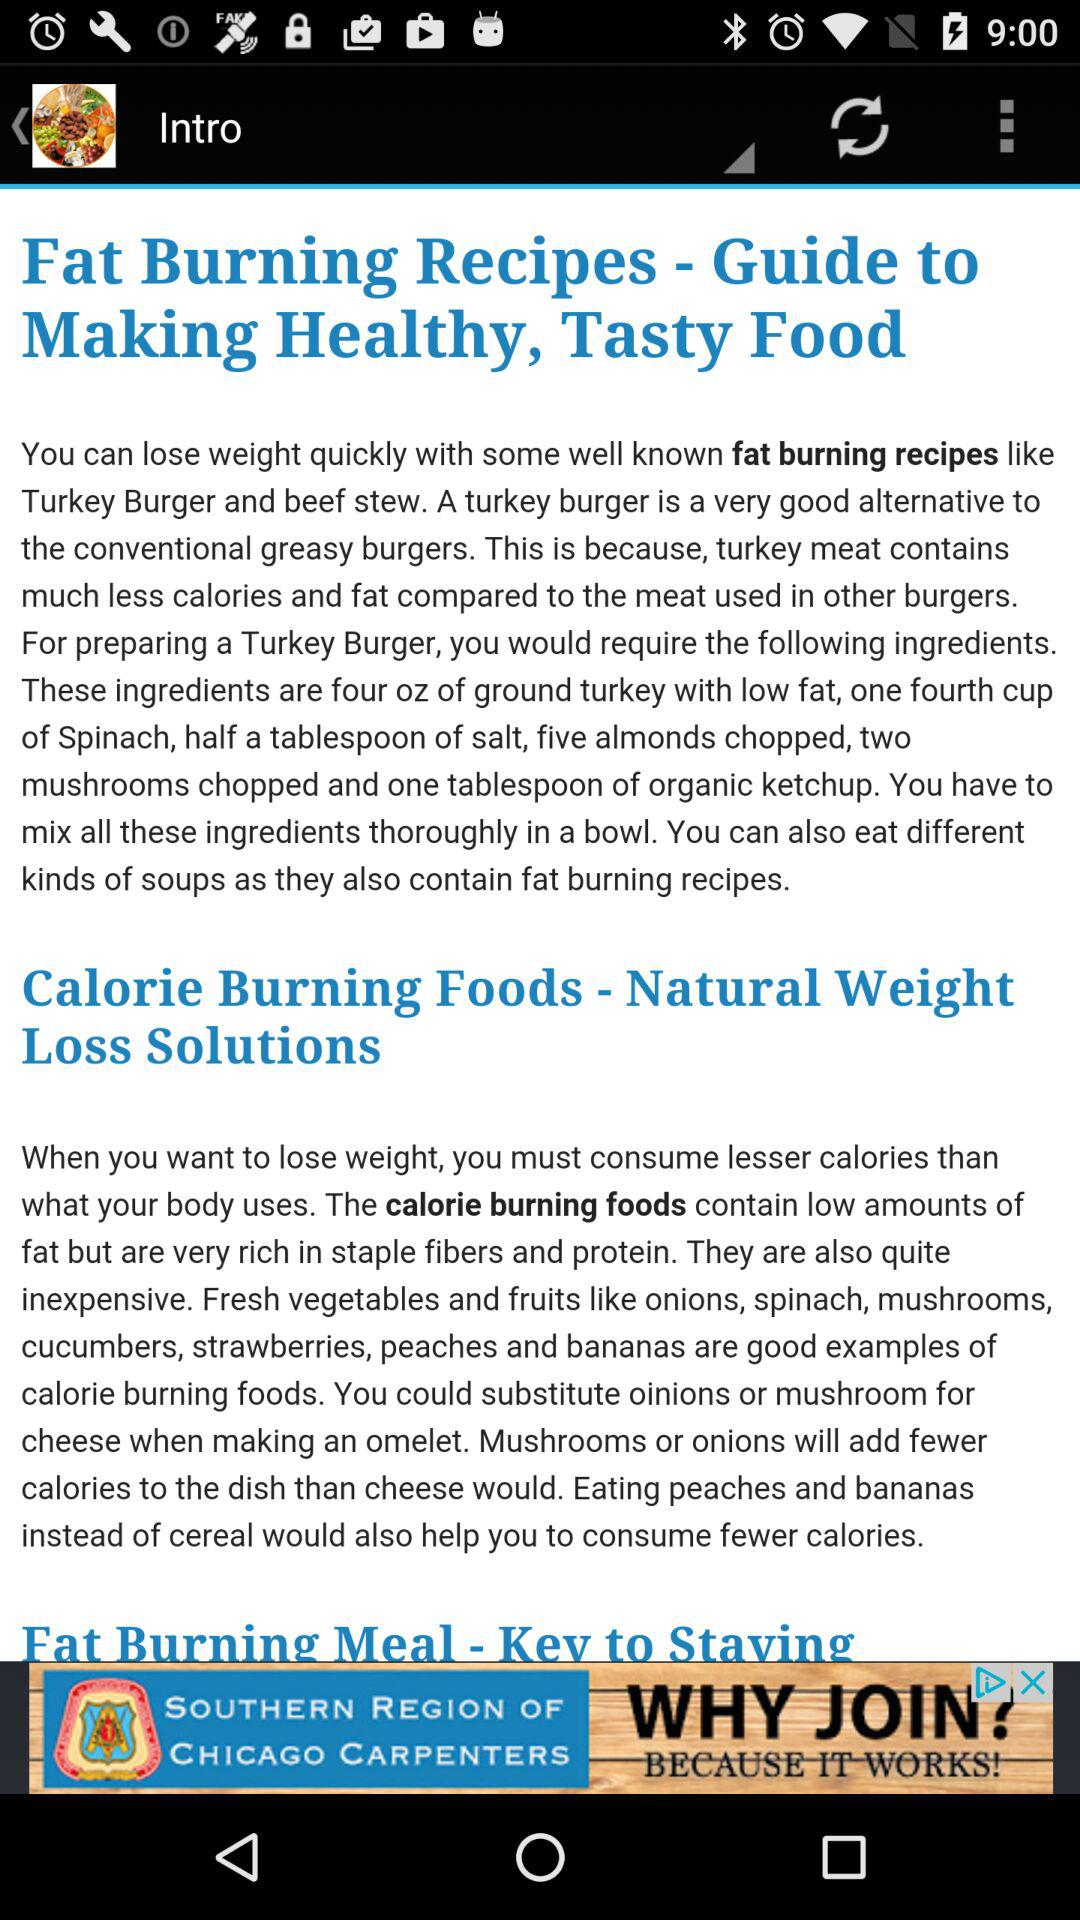What is the name of the fat burning recipe? The name of the fat burning recipes are "Turkey Burger" and "beef stew". 